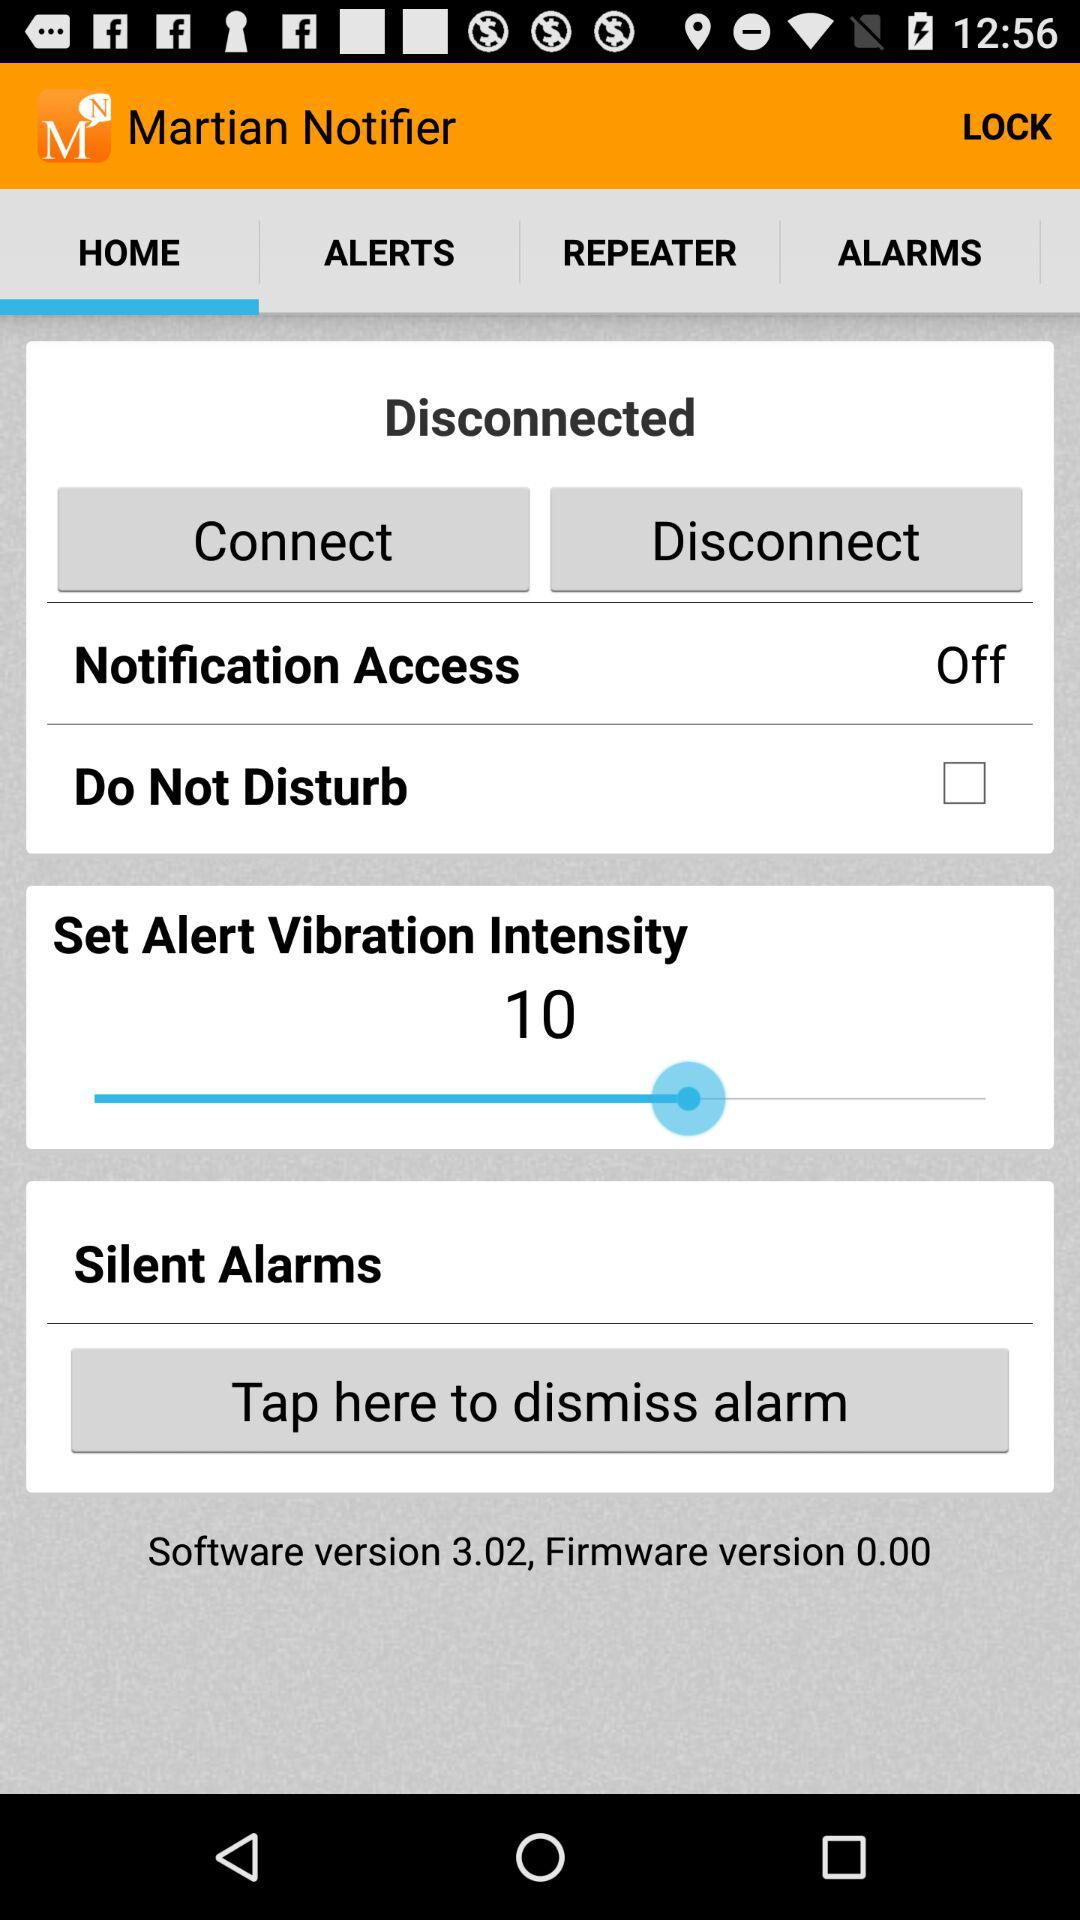How much vibration intensity is there? The vibration entity is 10. 